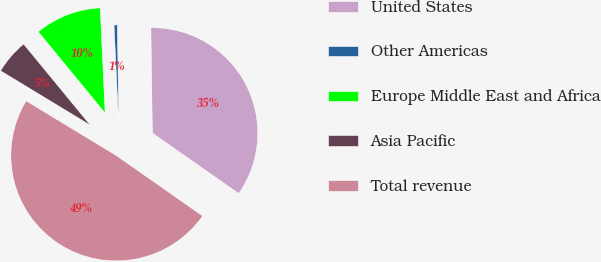Convert chart to OTSL. <chart><loc_0><loc_0><loc_500><loc_500><pie_chart><fcel>United States<fcel>Other Americas<fcel>Europe Middle East and Africa<fcel>Asia Pacific<fcel>Total revenue<nl><fcel>34.94%<fcel>0.52%<fcel>10.21%<fcel>5.37%<fcel>48.96%<nl></chart> 